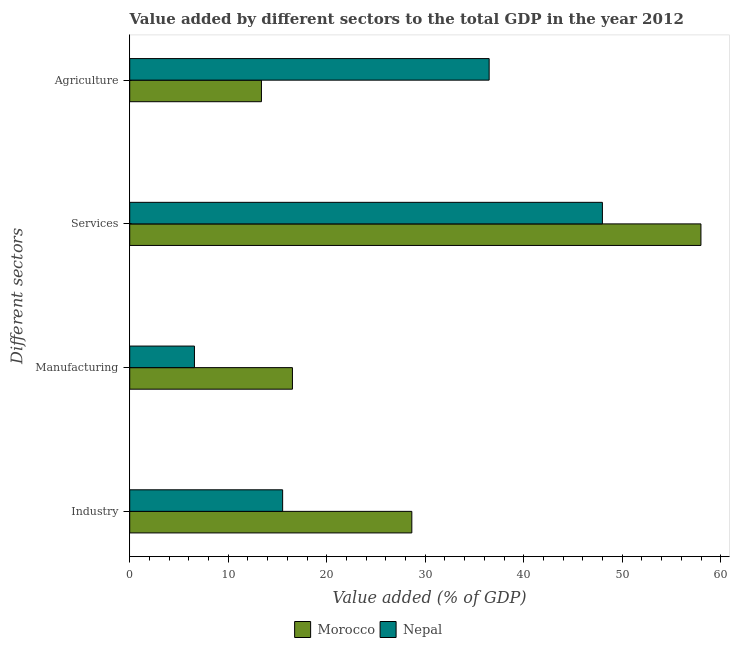How many different coloured bars are there?
Keep it short and to the point. 2. How many groups of bars are there?
Offer a terse response. 4. Are the number of bars on each tick of the Y-axis equal?
Offer a very short reply. Yes. How many bars are there on the 3rd tick from the top?
Your answer should be compact. 2. What is the label of the 1st group of bars from the top?
Ensure brevity in your answer.  Agriculture. What is the value added by agricultural sector in Nepal?
Your answer should be very brief. 36.49. Across all countries, what is the maximum value added by manufacturing sector?
Provide a succinct answer. 16.52. Across all countries, what is the minimum value added by manufacturing sector?
Provide a succinct answer. 6.57. In which country was the value added by services sector maximum?
Provide a short and direct response. Morocco. In which country was the value added by industrial sector minimum?
Give a very brief answer. Nepal. What is the total value added by manufacturing sector in the graph?
Provide a short and direct response. 23.09. What is the difference between the value added by manufacturing sector in Morocco and that in Nepal?
Make the answer very short. 9.95. What is the difference between the value added by agricultural sector in Morocco and the value added by services sector in Nepal?
Ensure brevity in your answer.  -34.62. What is the average value added by industrial sector per country?
Keep it short and to the point. 22.08. What is the difference between the value added by industrial sector and value added by agricultural sector in Morocco?
Your answer should be compact. 15.27. What is the ratio of the value added by agricultural sector in Morocco to that in Nepal?
Give a very brief answer. 0.37. Is the value added by industrial sector in Morocco less than that in Nepal?
Your answer should be compact. No. What is the difference between the highest and the second highest value added by agricultural sector?
Give a very brief answer. 23.12. What is the difference between the highest and the lowest value added by services sector?
Keep it short and to the point. 10. In how many countries, is the value added by services sector greater than the average value added by services sector taken over all countries?
Your response must be concise. 1. Is the sum of the value added by services sector in Nepal and Morocco greater than the maximum value added by agricultural sector across all countries?
Offer a terse response. Yes. What does the 1st bar from the top in Industry represents?
Your response must be concise. Nepal. What does the 2nd bar from the bottom in Manufacturing represents?
Keep it short and to the point. Nepal. How many countries are there in the graph?
Your response must be concise. 2. What is the title of the graph?
Offer a terse response. Value added by different sectors to the total GDP in the year 2012. What is the label or title of the X-axis?
Your answer should be very brief. Value added (% of GDP). What is the label or title of the Y-axis?
Offer a terse response. Different sectors. What is the Value added (% of GDP) in Morocco in Industry?
Offer a very short reply. 28.64. What is the Value added (% of GDP) in Nepal in Industry?
Your answer should be very brief. 15.52. What is the Value added (% of GDP) of Morocco in Manufacturing?
Keep it short and to the point. 16.52. What is the Value added (% of GDP) of Nepal in Manufacturing?
Provide a short and direct response. 6.57. What is the Value added (% of GDP) of Morocco in Services?
Offer a terse response. 57.99. What is the Value added (% of GDP) in Nepal in Services?
Your response must be concise. 47.99. What is the Value added (% of GDP) of Morocco in Agriculture?
Provide a succinct answer. 13.37. What is the Value added (% of GDP) of Nepal in Agriculture?
Give a very brief answer. 36.49. Across all Different sectors, what is the maximum Value added (% of GDP) in Morocco?
Ensure brevity in your answer.  57.99. Across all Different sectors, what is the maximum Value added (% of GDP) in Nepal?
Your response must be concise. 47.99. Across all Different sectors, what is the minimum Value added (% of GDP) in Morocco?
Give a very brief answer. 13.37. Across all Different sectors, what is the minimum Value added (% of GDP) in Nepal?
Provide a short and direct response. 6.57. What is the total Value added (% of GDP) in Morocco in the graph?
Provide a succinct answer. 116.52. What is the total Value added (% of GDP) of Nepal in the graph?
Your answer should be compact. 106.57. What is the difference between the Value added (% of GDP) of Morocco in Industry and that in Manufacturing?
Ensure brevity in your answer.  12.12. What is the difference between the Value added (% of GDP) in Nepal in Industry and that in Manufacturing?
Make the answer very short. 8.95. What is the difference between the Value added (% of GDP) of Morocco in Industry and that in Services?
Your answer should be very brief. -29.35. What is the difference between the Value added (% of GDP) in Nepal in Industry and that in Services?
Provide a short and direct response. -32.46. What is the difference between the Value added (% of GDP) in Morocco in Industry and that in Agriculture?
Make the answer very short. 15.27. What is the difference between the Value added (% of GDP) of Nepal in Industry and that in Agriculture?
Keep it short and to the point. -20.97. What is the difference between the Value added (% of GDP) in Morocco in Manufacturing and that in Services?
Provide a short and direct response. -41.47. What is the difference between the Value added (% of GDP) of Nepal in Manufacturing and that in Services?
Ensure brevity in your answer.  -41.42. What is the difference between the Value added (% of GDP) of Morocco in Manufacturing and that in Agriculture?
Give a very brief answer. 3.15. What is the difference between the Value added (% of GDP) of Nepal in Manufacturing and that in Agriculture?
Ensure brevity in your answer.  -29.92. What is the difference between the Value added (% of GDP) of Morocco in Services and that in Agriculture?
Your answer should be very brief. 44.62. What is the difference between the Value added (% of GDP) in Nepal in Services and that in Agriculture?
Your answer should be very brief. 11.5. What is the difference between the Value added (% of GDP) in Morocco in Industry and the Value added (% of GDP) in Nepal in Manufacturing?
Offer a very short reply. 22.07. What is the difference between the Value added (% of GDP) of Morocco in Industry and the Value added (% of GDP) of Nepal in Services?
Give a very brief answer. -19.35. What is the difference between the Value added (% of GDP) of Morocco in Industry and the Value added (% of GDP) of Nepal in Agriculture?
Keep it short and to the point. -7.85. What is the difference between the Value added (% of GDP) of Morocco in Manufacturing and the Value added (% of GDP) of Nepal in Services?
Make the answer very short. -31.47. What is the difference between the Value added (% of GDP) in Morocco in Manufacturing and the Value added (% of GDP) in Nepal in Agriculture?
Ensure brevity in your answer.  -19.97. What is the difference between the Value added (% of GDP) in Morocco in Services and the Value added (% of GDP) in Nepal in Agriculture?
Offer a very short reply. 21.5. What is the average Value added (% of GDP) of Morocco per Different sectors?
Keep it short and to the point. 29.13. What is the average Value added (% of GDP) of Nepal per Different sectors?
Keep it short and to the point. 26.64. What is the difference between the Value added (% of GDP) of Morocco and Value added (% of GDP) of Nepal in Industry?
Your response must be concise. 13.12. What is the difference between the Value added (% of GDP) of Morocco and Value added (% of GDP) of Nepal in Manufacturing?
Your answer should be compact. 9.95. What is the difference between the Value added (% of GDP) of Morocco and Value added (% of GDP) of Nepal in Services?
Provide a succinct answer. 10. What is the difference between the Value added (% of GDP) of Morocco and Value added (% of GDP) of Nepal in Agriculture?
Offer a very short reply. -23.12. What is the ratio of the Value added (% of GDP) of Morocco in Industry to that in Manufacturing?
Give a very brief answer. 1.73. What is the ratio of the Value added (% of GDP) in Nepal in Industry to that in Manufacturing?
Provide a short and direct response. 2.36. What is the ratio of the Value added (% of GDP) in Morocco in Industry to that in Services?
Ensure brevity in your answer.  0.49. What is the ratio of the Value added (% of GDP) in Nepal in Industry to that in Services?
Offer a terse response. 0.32. What is the ratio of the Value added (% of GDP) of Morocco in Industry to that in Agriculture?
Offer a very short reply. 2.14. What is the ratio of the Value added (% of GDP) of Nepal in Industry to that in Agriculture?
Provide a succinct answer. 0.43. What is the ratio of the Value added (% of GDP) of Morocco in Manufacturing to that in Services?
Offer a terse response. 0.28. What is the ratio of the Value added (% of GDP) in Nepal in Manufacturing to that in Services?
Offer a terse response. 0.14. What is the ratio of the Value added (% of GDP) in Morocco in Manufacturing to that in Agriculture?
Your answer should be very brief. 1.24. What is the ratio of the Value added (% of GDP) in Nepal in Manufacturing to that in Agriculture?
Keep it short and to the point. 0.18. What is the ratio of the Value added (% of GDP) of Morocco in Services to that in Agriculture?
Your answer should be compact. 4.34. What is the ratio of the Value added (% of GDP) of Nepal in Services to that in Agriculture?
Offer a terse response. 1.32. What is the difference between the highest and the second highest Value added (% of GDP) of Morocco?
Offer a very short reply. 29.35. What is the difference between the highest and the second highest Value added (% of GDP) in Nepal?
Offer a terse response. 11.5. What is the difference between the highest and the lowest Value added (% of GDP) in Morocco?
Offer a very short reply. 44.62. What is the difference between the highest and the lowest Value added (% of GDP) of Nepal?
Ensure brevity in your answer.  41.42. 